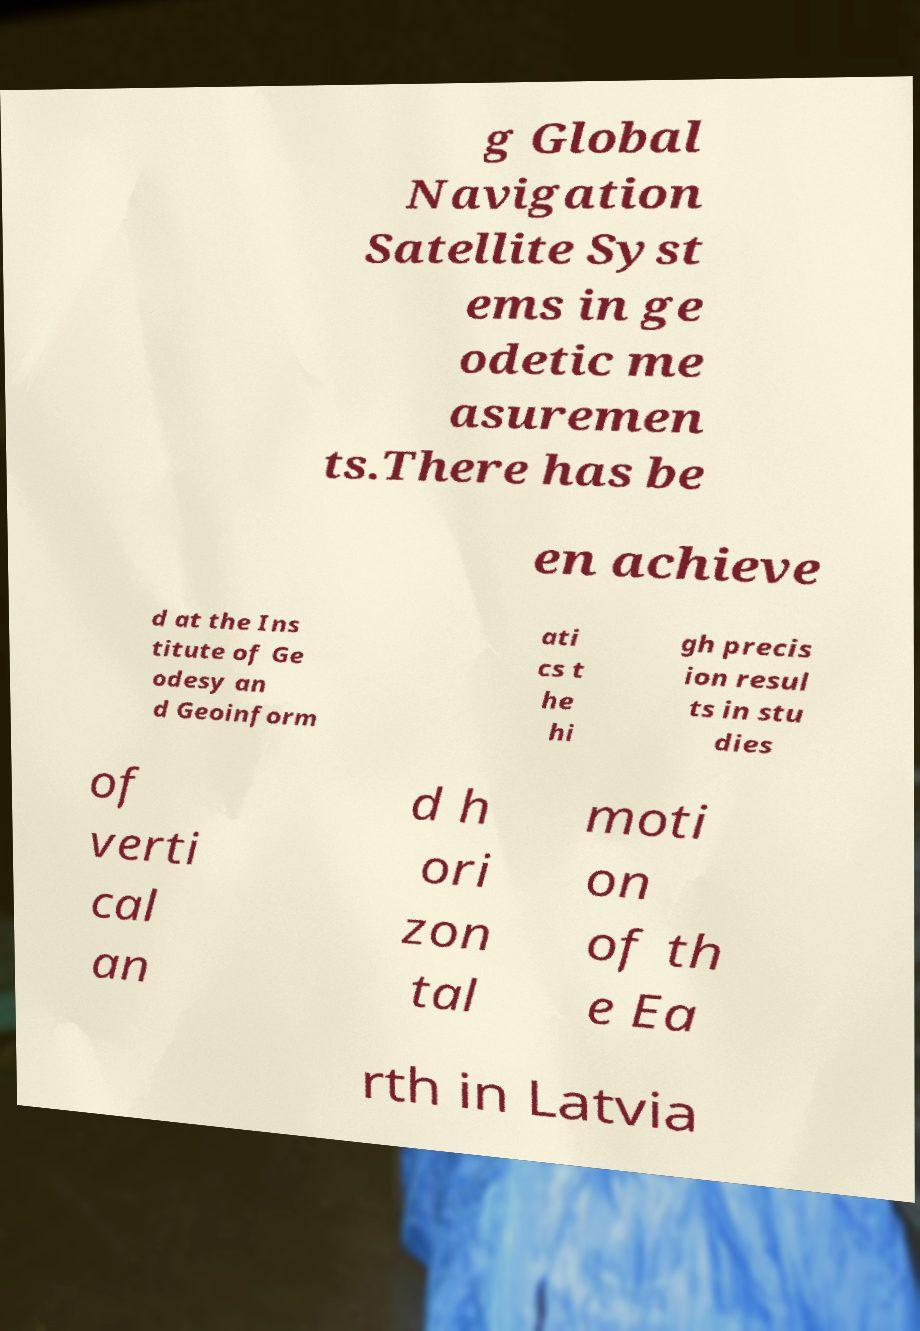What messages or text are displayed in this image? I need them in a readable, typed format. g Global Navigation Satellite Syst ems in ge odetic me asuremen ts.There has be en achieve d at the Ins titute of Ge odesy an d Geoinform ati cs t he hi gh precis ion resul ts in stu dies of verti cal an d h ori zon tal moti on of th e Ea rth in Latvia 